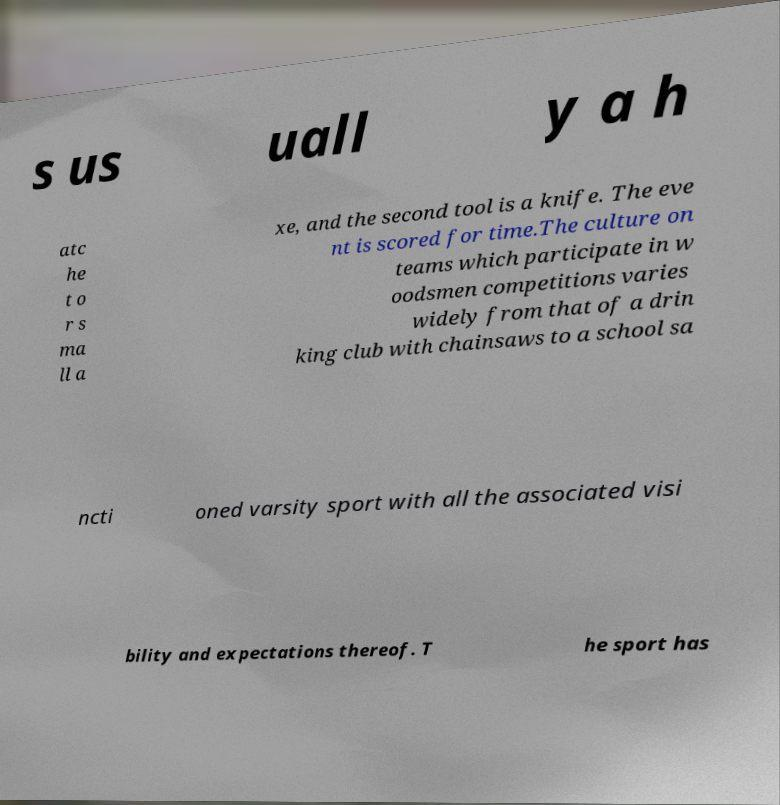Could you assist in decoding the text presented in this image and type it out clearly? s us uall y a h atc he t o r s ma ll a xe, and the second tool is a knife. The eve nt is scored for time.The culture on teams which participate in w oodsmen competitions varies widely from that of a drin king club with chainsaws to a school sa ncti oned varsity sport with all the associated visi bility and expectations thereof. T he sport has 